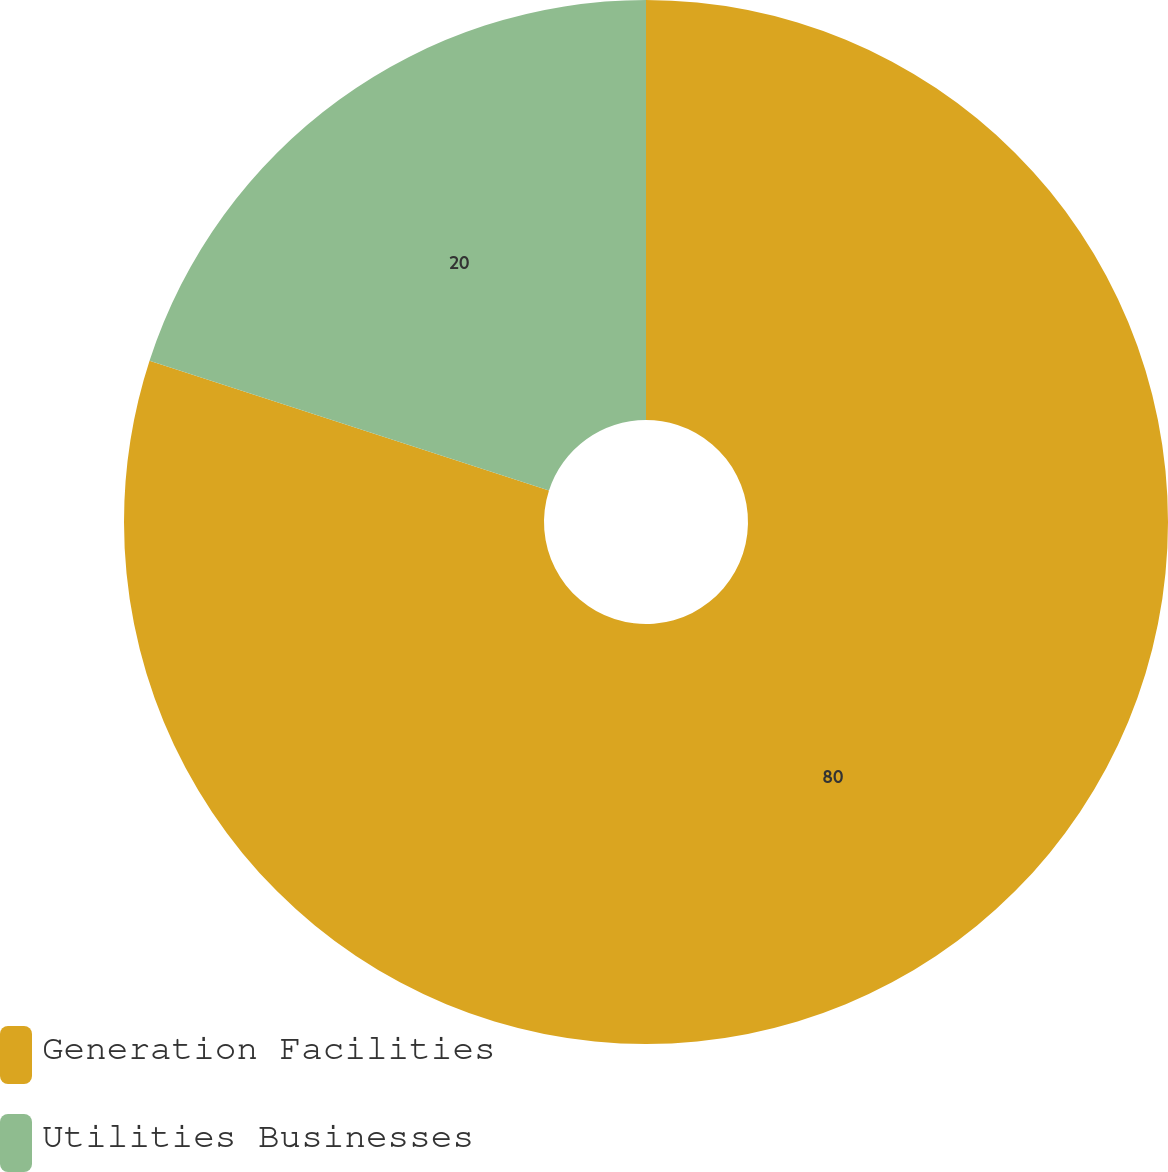<chart> <loc_0><loc_0><loc_500><loc_500><pie_chart><fcel>Generation Facilities<fcel>Utilities Businesses<nl><fcel>80.0%<fcel>20.0%<nl></chart> 